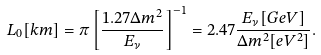Convert formula to latex. <formula><loc_0><loc_0><loc_500><loc_500>L _ { 0 } [ k m ] = \pi \left [ \frac { 1 . 2 7 \Delta m ^ { 2 } } { E _ { \nu } } \right ] ^ { - 1 } = 2 . 4 7 \frac { E _ { \nu } [ G e V ] } { \Delta m ^ { 2 } [ e V ^ { 2 } ] } .</formula> 